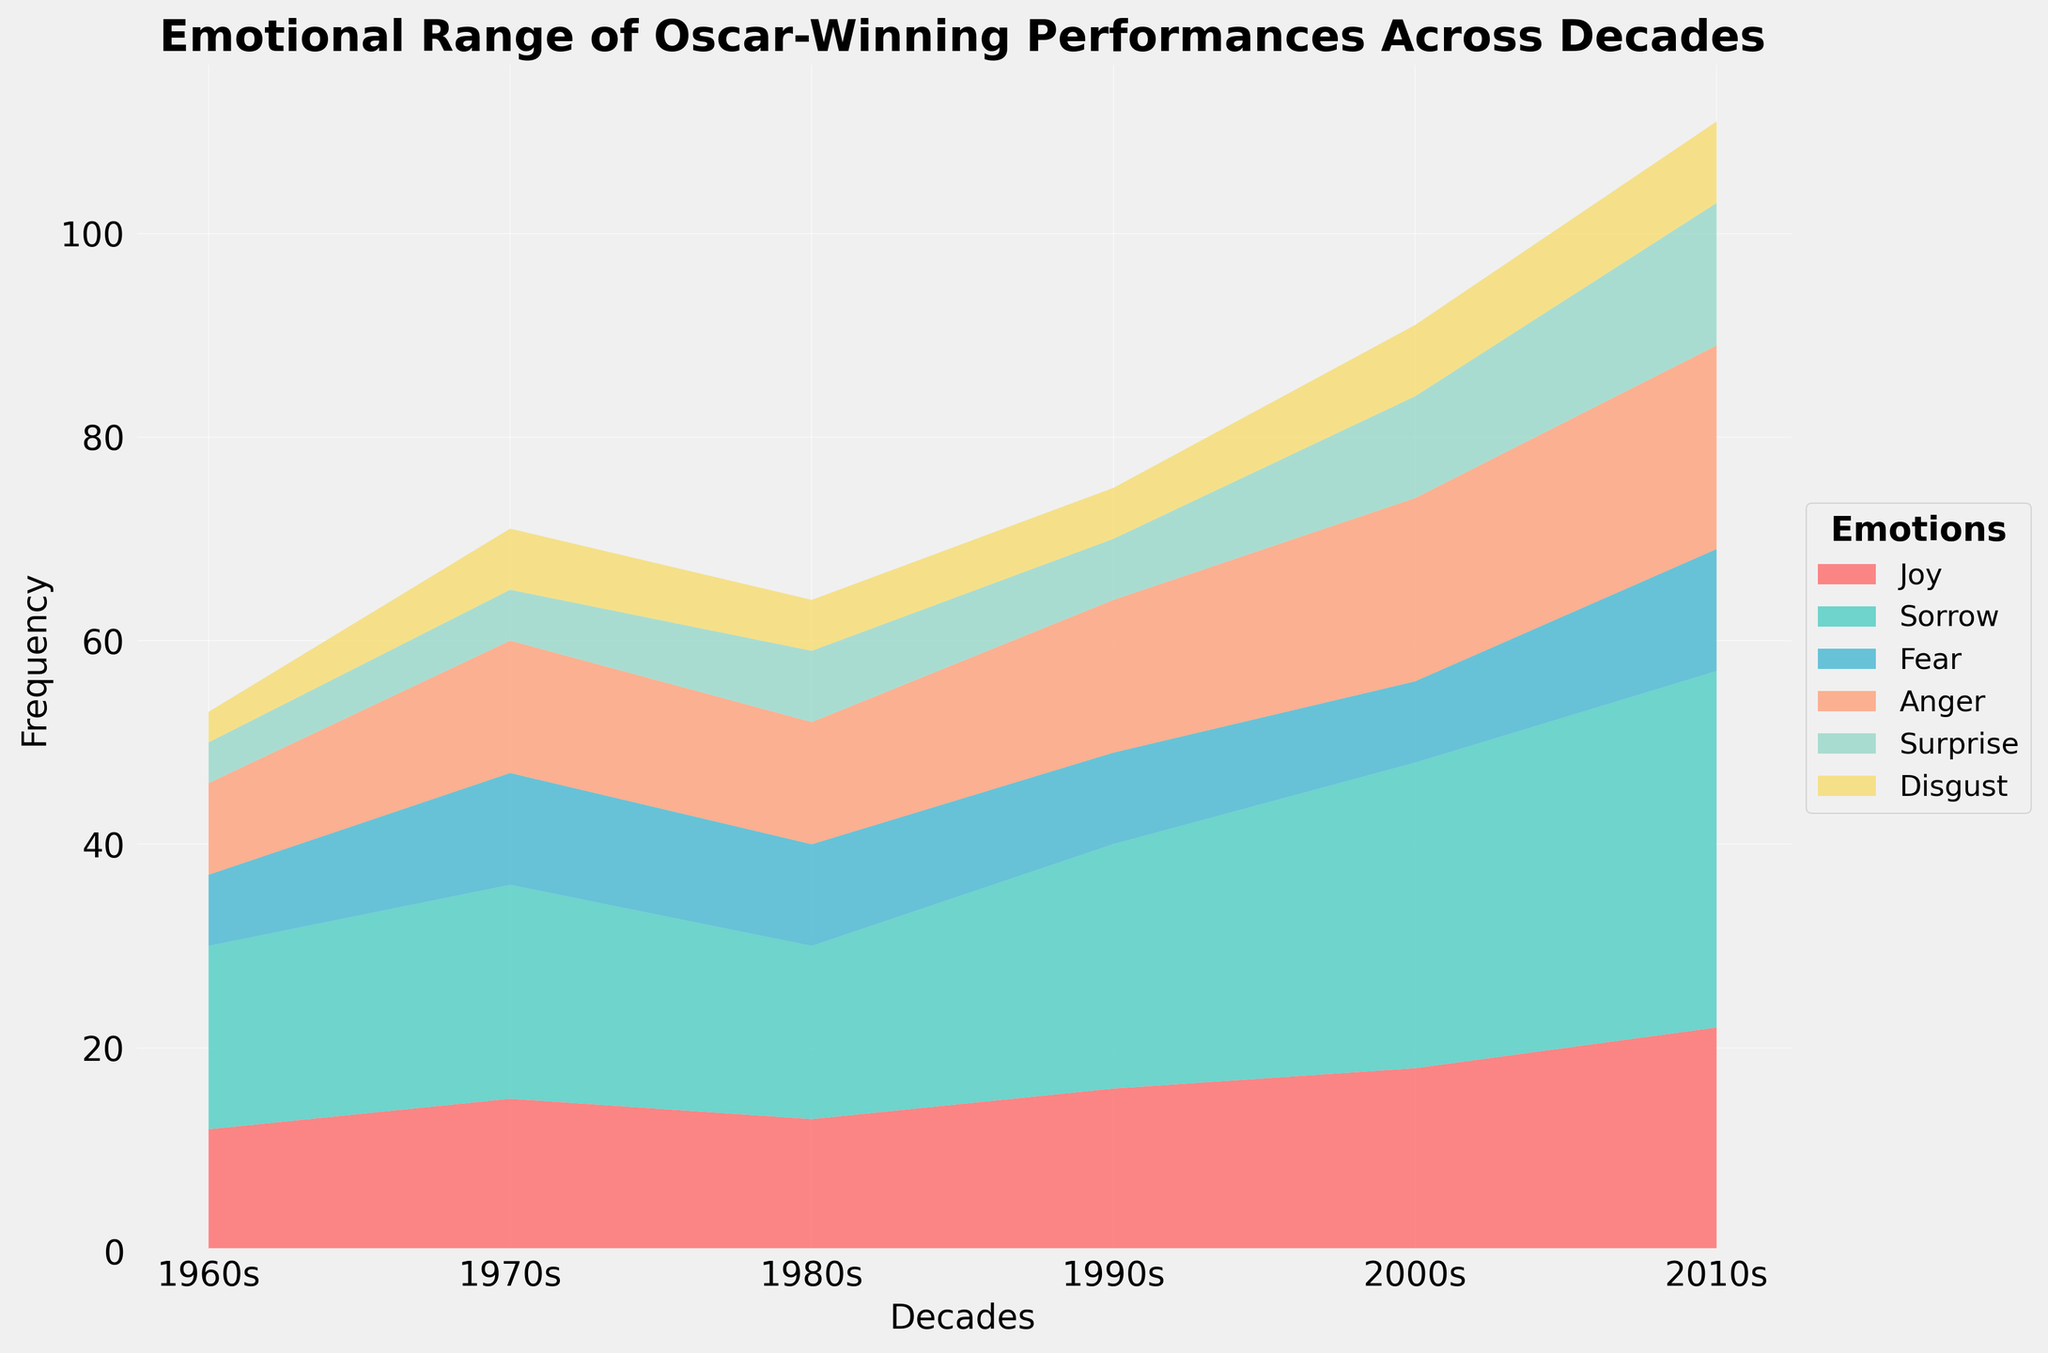Which emotion has the highest frequency in the 2010s? Based on the figure, find the segment that extends the furthest vertically within the 2010s. Sorrow appears to be the most prominent.
Answer: Sorrow What is the total frequency of "Joy" across all decades? For each decade, locate the "Joy" segment and sum the numbers: 12 (1960s) + 15 (1970s) + 13 (1980s) + 16 (1990s) + 18 (2000s) + 22 (2010s).
Answer: 96 Which decade shows the highest overall frequency for any single emotion? Observe the peak of each streamline for each emotion across all decades. The 2010s show Sorrow at a peak of 35, which is the highest.
Answer: 2010s In which decade did "Anger" see its peak frequency? Look along the "Anger" color streamline and identify the decade with the highest vertical extent. The highest value for Anger is 20, which occurs in the 2010s.
Answer: 2010s How does the frequency of "Disgust" in the 2000s compare to the 1990s? Locate the "Disgust" segments for the 1990s and 2000s and compare their frequencies: 5 in the 1990s and 7 in the 2000s.
Answer: 7 is greater than 5 What is the difference in frequency of "Fear" between the 1960s and the 2010s? Subtract the frequency of "Fear" in the 1960s (7) from the frequency in the 2010s (12).
Answer: 5 Which emotion had the least change in frequency from the 1960s to the 2010s? Calculate the absolute difference in frequency for each emotion between the two decades. "Disgust" changes from 3 in the 1960s to 8 in the 2010s, which is 5, compared to 10 for others.
Answer: Disgust What is the combined frequency of "Surprise" and "Joy" in the 2010s? Add the frequencies of "Surprise" (14) and "Joy" (22) in the 2010s.
Answer: 36 Which decade experienced the most balanced emotional representation (least variability in frequencies of different emotions)? Compare the range (difference between max and min) of frequencies for each decade. The 1980s have the smallest range from 5 (Disgust) to 17 (Sorrow), which is 12.
Answer: 1980s 